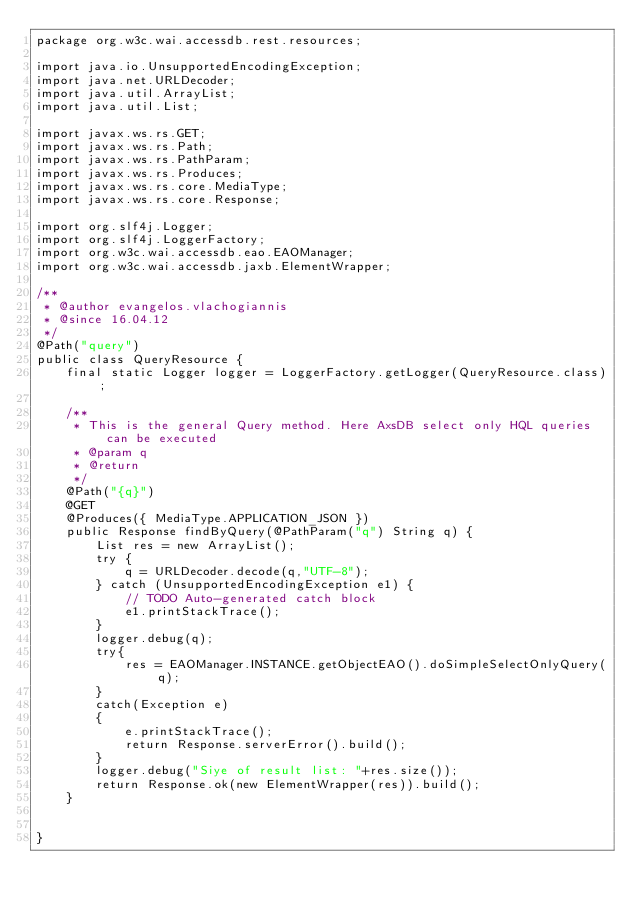Convert code to text. <code><loc_0><loc_0><loc_500><loc_500><_Java_>package org.w3c.wai.accessdb.rest.resources;

import java.io.UnsupportedEncodingException;
import java.net.URLDecoder;
import java.util.ArrayList;
import java.util.List;

import javax.ws.rs.GET;
import javax.ws.rs.Path;
import javax.ws.rs.PathParam;
import javax.ws.rs.Produces;
import javax.ws.rs.core.MediaType;
import javax.ws.rs.core.Response;

import org.slf4j.Logger;
import org.slf4j.LoggerFactory;
import org.w3c.wai.accessdb.eao.EAOManager;
import org.w3c.wai.accessdb.jaxb.ElementWrapper;

/**
 * @author evangelos.vlachogiannis
 * @since 16.04.12
 */
@Path("query")
public class QueryResource {
	final static Logger logger = LoggerFactory.getLogger(QueryResource.class);
	
	/**
	 * This is the general Query method. Here AxsDB select only HQL queries can be executed
	 * @param q
	 * @return
	 */
	@Path("{q}") 
	@GET	
	@Produces({ MediaType.APPLICATION_JSON })
	public Response findByQuery(@PathParam("q") String q) {
		List res = new ArrayList();
		try {
			q = URLDecoder.decode(q,"UTF-8"); 
		} catch (UnsupportedEncodingException e1) {
			// TODO Auto-generated catch block
			e1.printStackTrace();
		}
		logger.debug(q);
		try{
			res = EAOManager.INSTANCE.getObjectEAO().doSimpleSelectOnlyQuery(q);	
		}
		catch(Exception e)
		{
			e.printStackTrace();
			return Response.serverError().build();
		}
		logger.debug("Siye of result list: "+res.size());
		return Response.ok(new ElementWrapper(res)).build();
	}
	
	
}
</code> 